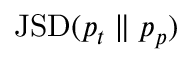<formula> <loc_0><loc_0><loc_500><loc_500>J S D ( p _ { t } \| p _ { p } )</formula> 